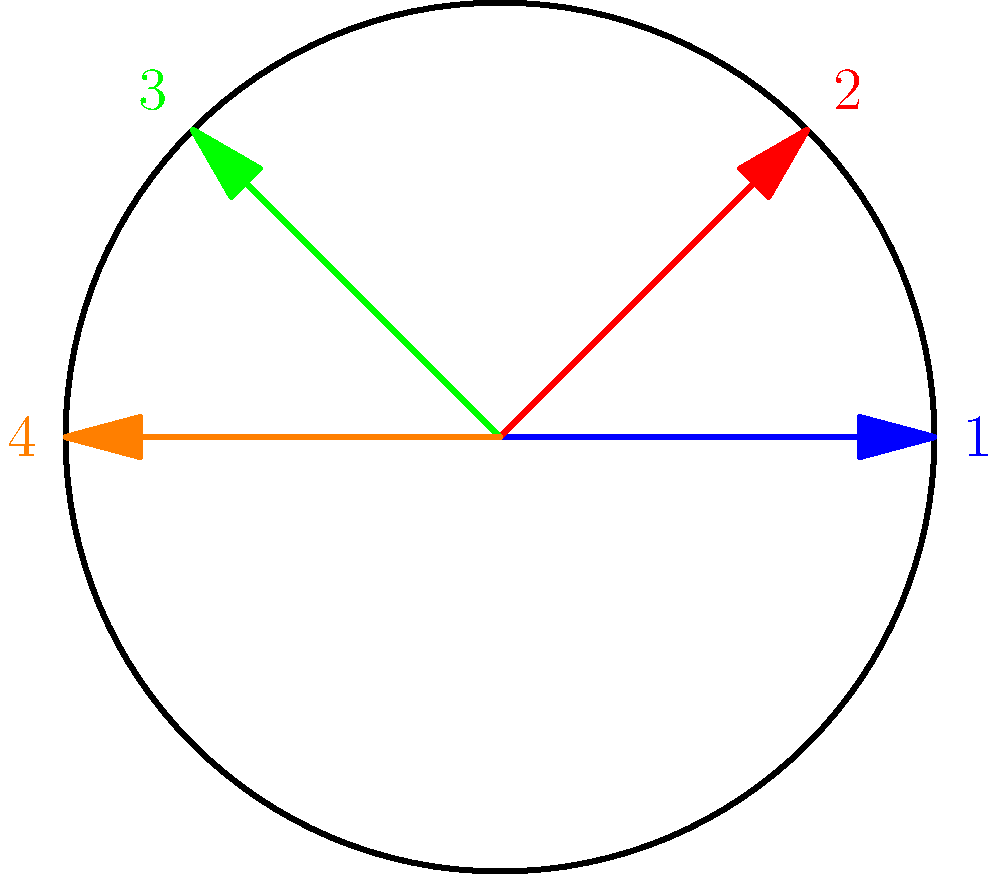In a circular equestrian arena, four riders are positioned at equal intervals around the edge, facing the center. The arena manager wants to rotate the formation clockwise by 90°. How many 90° rotations are needed to return the riders to their original positions? Express your answer in terms of the order of the cyclic group generated by this rotation. Let's approach this step-by-step:

1) First, we need to understand what a 90° clockwise rotation does:
   - Rider 1 (blue) moves to position 4 (orange)
   - Rider 2 (red) moves to position 1 (blue)
   - Rider 3 (green) moves to position 2 (red)
   - Rider 4 (orange) moves to position 3 (green)

2) We can represent this as a permutation: (1 4 3 2)

3) To find how many rotations are needed to return to the original position, we need to apply this permutation repeatedly until we get back to (1 2 3 4):
   - After 1 rotation: (1 4 3 2)
   - After 2 rotations: (1 3 2 4)
   - After 3 rotations: (1 2 4 3)
   - After 4 rotations: (1 2 3 4) - back to the original position

4) It takes 4 rotations to return to the original position.

5) In group theory, this means that the order of the cyclic group generated by this rotation is 4.

Therefore, the number of 90° rotations needed is equal to the order of the cyclic group generated by this rotation, which is 4.
Answer: 4 